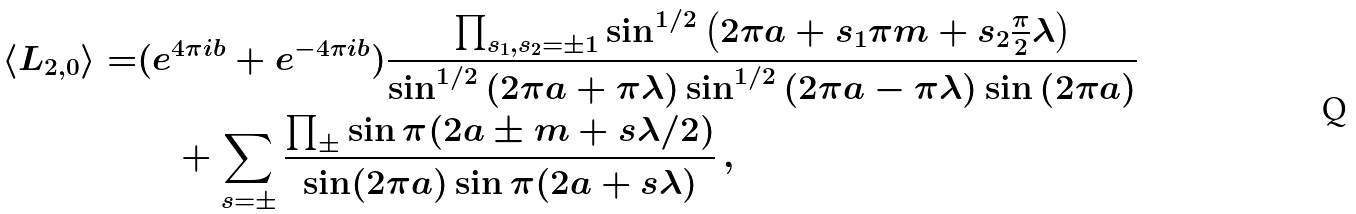<formula> <loc_0><loc_0><loc_500><loc_500>\langle L _ { 2 , 0 } \rangle = & ( e ^ { 4 \pi i b } + e ^ { - 4 \pi i b } ) \frac { \prod _ { s _ { 1 } , s _ { 2 } = \pm 1 } \sin ^ { 1 / 2 } \left ( 2 \pi a + s _ { 1 } \pi m + s _ { 2 } \frac { \pi } { 2 } \lambda \right ) } { \sin ^ { 1 / 2 } \left ( 2 \pi a + \pi \lambda \right ) \sin ^ { 1 / 2 } \left ( 2 \pi a - \pi \lambda \right ) \sin \left ( 2 \pi a \right ) } \\ & \quad + \sum _ { s = \pm } \frac { \prod _ { \pm } \sin \pi ( 2 a \pm m + s \lambda / 2 ) } { \sin ( 2 \pi a ) \sin \pi ( 2 a + s \lambda ) } \, ,</formula> 